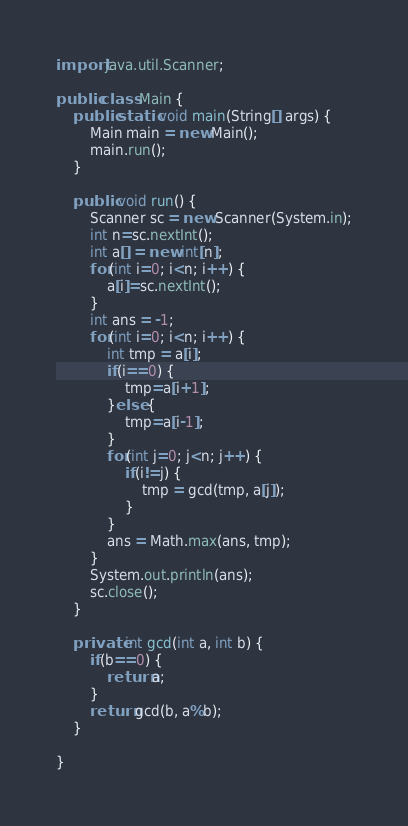Convert code to text. <code><loc_0><loc_0><loc_500><loc_500><_Java_>import java.util.Scanner;

public class Main {
	public static void main(String[] args) {
		Main main = new Main();
		main.run();
	}

	public void run() {
		Scanner sc = new Scanner(System.in);
		int n=sc.nextInt();
		int a[] = new int[n];
		for(int i=0; i<n; i++) {
			a[i]=sc.nextInt();
		}
		int ans = -1;
		for(int i=0; i<n; i++) {
			int tmp = a[i];
			if(i==0) {
				tmp=a[i+1];
			}else {
				tmp=a[i-1];
			}
			for(int j=0; j<n; j++) {
				if(i!=j) {
					tmp = gcd(tmp, a[j]);
				}
			}
			ans = Math.max(ans, tmp);
		}
		System.out.println(ans);
		sc.close();
	}

	private int gcd(int a, int b) {
		if(b==0) {
			return a;
		}
		return gcd(b, a%b);
	}

}
</code> 